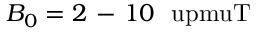<formula> <loc_0><loc_0><loc_500><loc_500>B _ { 0 } = 2 - 1 0 \ u p m u T</formula> 